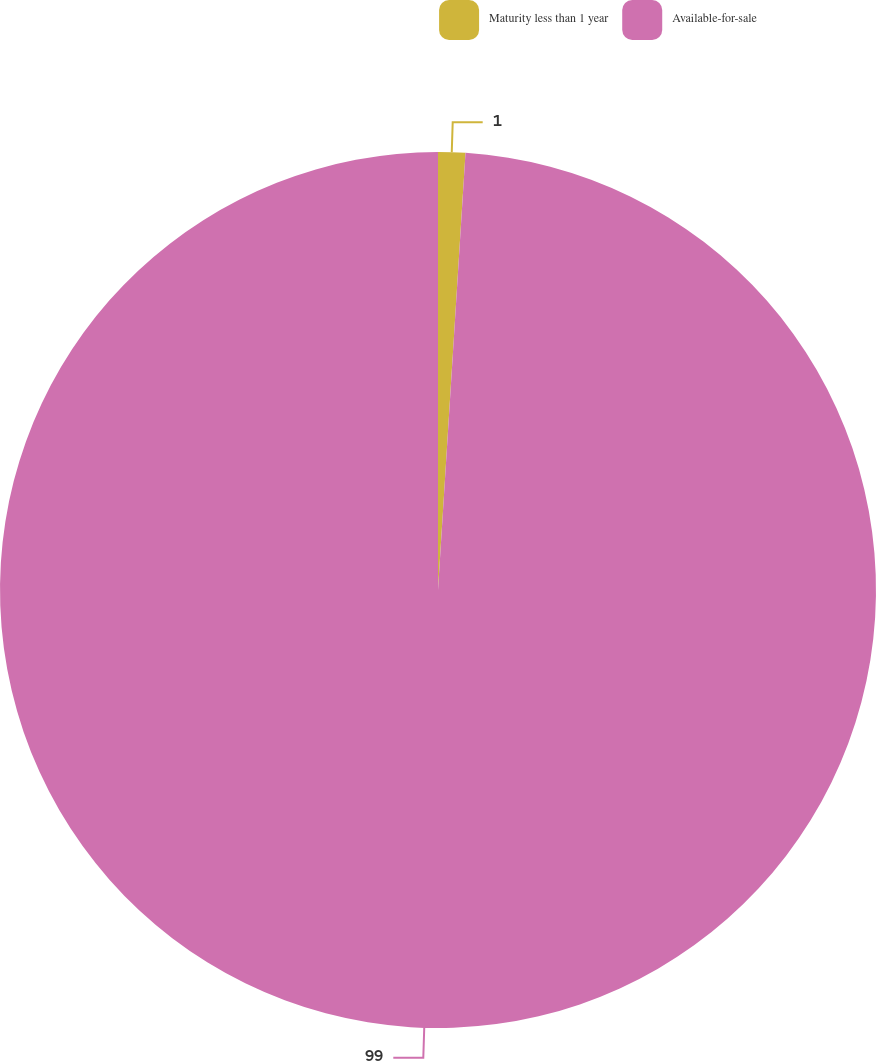<chart> <loc_0><loc_0><loc_500><loc_500><pie_chart><fcel>Maturity less than 1 year<fcel>Available-for-sale<nl><fcel>1.0%<fcel>99.0%<nl></chart> 